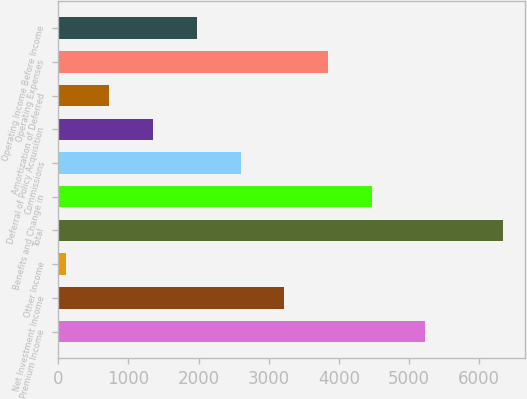Convert chart to OTSL. <chart><loc_0><loc_0><loc_500><loc_500><bar_chart><fcel>Premium Income<fcel>Net Investment Income<fcel>Other Income<fcel>Total<fcel>Benefits and Change in<fcel>Commissions<fcel>Deferral of Policy Acquisition<fcel>Amortization of Deferred<fcel>Operating Expenses<fcel>Operating Income Before Income<nl><fcel>5229<fcel>3222.2<fcel>108.6<fcel>6335.8<fcel>4467.64<fcel>2599.48<fcel>1354.04<fcel>731.32<fcel>3844.92<fcel>1976.76<nl></chart> 